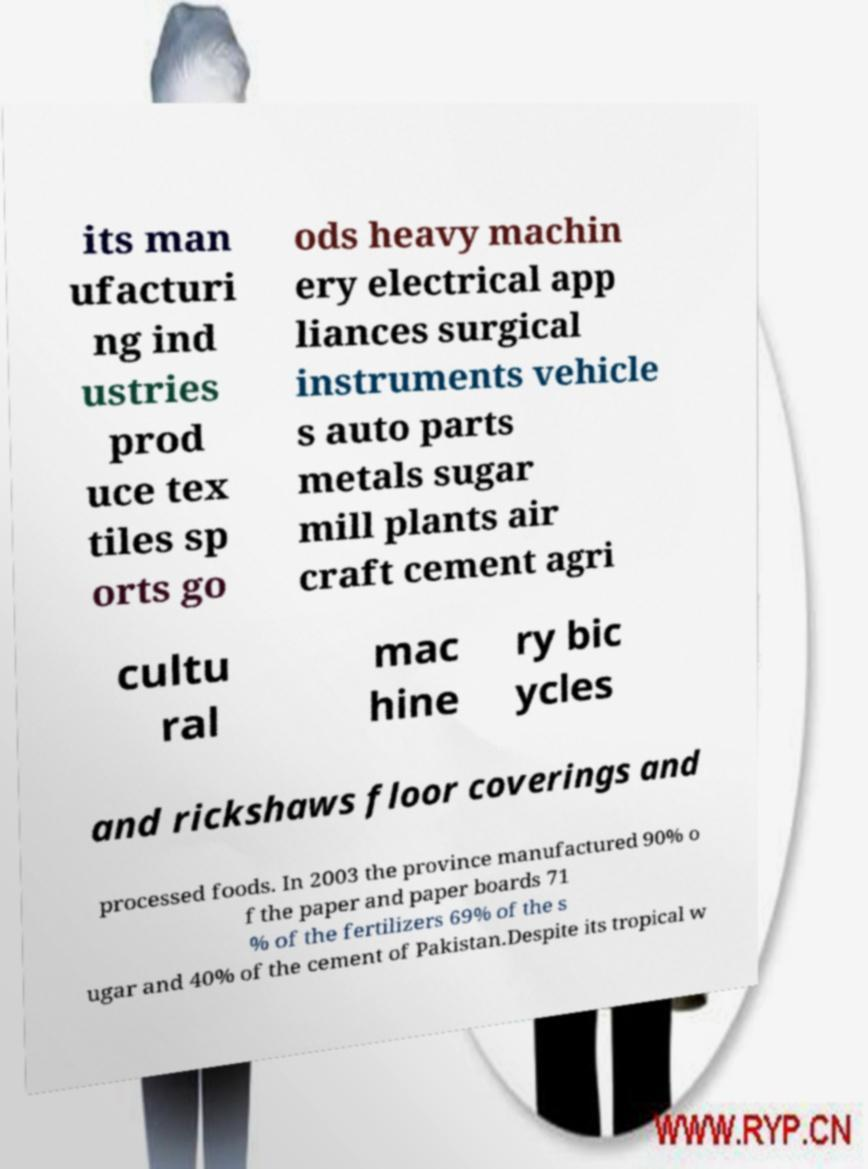Can you accurately transcribe the text from the provided image for me? its man ufacturi ng ind ustries prod uce tex tiles sp orts go ods heavy machin ery electrical app liances surgical instruments vehicle s auto parts metals sugar mill plants air craft cement agri cultu ral mac hine ry bic ycles and rickshaws floor coverings and processed foods. In 2003 the province manufactured 90% o f the paper and paper boards 71 % of the fertilizers 69% of the s ugar and 40% of the cement of Pakistan.Despite its tropical w 